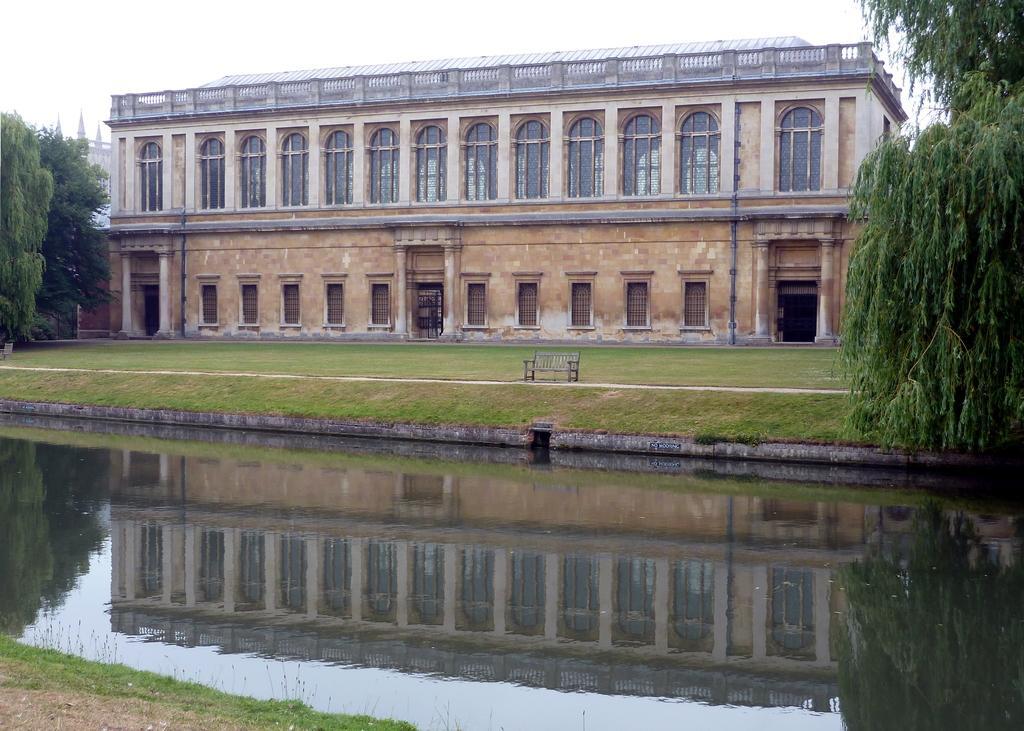How would you summarize this image in a sentence or two? In this we can see a bench on the path and in front of the bench there is water and behind the bench there are buildings, trees and sky. 